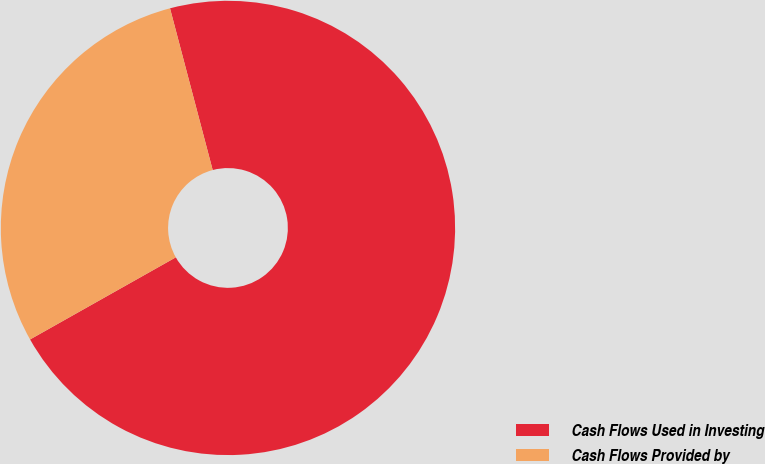<chart> <loc_0><loc_0><loc_500><loc_500><pie_chart><fcel>Cash Flows Used in Investing<fcel>Cash Flows Provided by<nl><fcel>70.94%<fcel>29.06%<nl></chart> 